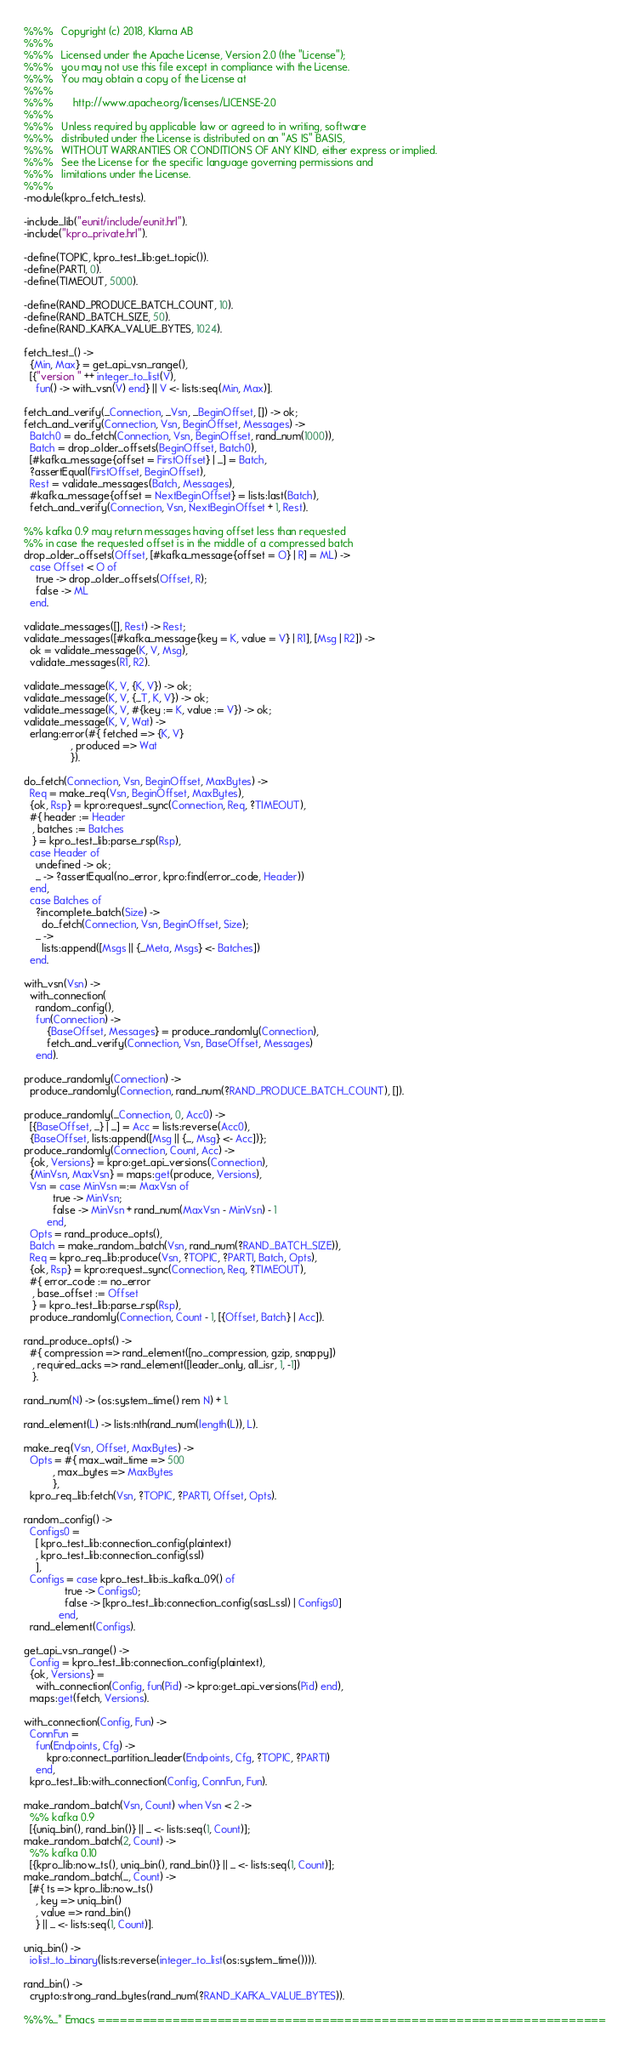<code> <loc_0><loc_0><loc_500><loc_500><_Erlang_>%%%   Copyright (c) 2018, Klarna AB
%%%
%%%   Licensed under the Apache License, Version 2.0 (the "License");
%%%   you may not use this file except in compliance with the License.
%%%   You may obtain a copy of the License at
%%%
%%%       http://www.apache.org/licenses/LICENSE-2.0
%%%
%%%   Unless required by applicable law or agreed to in writing, software
%%%   distributed under the License is distributed on an "AS IS" BASIS,
%%%   WITHOUT WARRANTIES OR CONDITIONS OF ANY KIND, either express or implied.
%%%   See the License for the specific language governing permissions and
%%%   limitations under the License.
%%%
-module(kpro_fetch_tests).

-include_lib("eunit/include/eunit.hrl").
-include("kpro_private.hrl").

-define(TOPIC, kpro_test_lib:get_topic()).
-define(PARTI, 0).
-define(TIMEOUT, 5000).

-define(RAND_PRODUCE_BATCH_COUNT, 10).
-define(RAND_BATCH_SIZE, 50).
-define(RAND_KAFKA_VALUE_BYTES, 1024).

fetch_test_() ->
  {Min, Max} = get_api_vsn_range(),
  [{"version " ++ integer_to_list(V),
    fun() -> with_vsn(V) end} || V <- lists:seq(Min, Max)].

fetch_and_verify(_Connection, _Vsn, _BeginOffset, []) -> ok;
fetch_and_verify(Connection, Vsn, BeginOffset, Messages) ->
  Batch0 = do_fetch(Connection, Vsn, BeginOffset, rand_num(1000)),
  Batch = drop_older_offsets(BeginOffset, Batch0),
  [#kafka_message{offset = FirstOffset} | _] = Batch,
  ?assertEqual(FirstOffset, BeginOffset),
  Rest = validate_messages(Batch, Messages),
  #kafka_message{offset = NextBeginOffset} = lists:last(Batch),
  fetch_and_verify(Connection, Vsn, NextBeginOffset + 1, Rest).

%% kafka 0.9 may return messages having offset less than requested
%% in case the requested offset is in the middle of a compressed batch
drop_older_offsets(Offset, [#kafka_message{offset = O} | R] = ML) ->
  case Offset < O of
    true -> drop_older_offsets(Offset, R);
    false -> ML
  end.

validate_messages([], Rest) -> Rest;
validate_messages([#kafka_message{key = K, value = V} | R1], [Msg | R2]) ->
  ok = validate_message(K, V, Msg),
  validate_messages(R1, R2).

validate_message(K, V, {K, V}) -> ok;
validate_message(K, V, {_T, K, V}) -> ok;
validate_message(K, V, #{key := K, value := V}) -> ok;
validate_message(K, V, Wat) ->
  erlang:error(#{ fetched => {K, V}
                , produced => Wat
                }).

do_fetch(Connection, Vsn, BeginOffset, MaxBytes) ->
  Req = make_req(Vsn, BeginOffset, MaxBytes),
  {ok, Rsp} = kpro:request_sync(Connection, Req, ?TIMEOUT),
  #{ header := Header
   , batches := Batches
   } = kpro_test_lib:parse_rsp(Rsp),
  case Header of
    undefined -> ok;
    _ -> ?assertEqual(no_error, kpro:find(error_code, Header))
  end,
  case Batches of
    ?incomplete_batch(Size) ->
      do_fetch(Connection, Vsn, BeginOffset, Size);
    _ ->
      lists:append([Msgs || {_Meta, Msgs} <- Batches])
  end.

with_vsn(Vsn) ->
  with_connection(
    random_config(),
    fun(Connection) ->
        {BaseOffset, Messages} = produce_randomly(Connection),
        fetch_and_verify(Connection, Vsn, BaseOffset, Messages)
    end).

produce_randomly(Connection) ->
  produce_randomly(Connection, rand_num(?RAND_PRODUCE_BATCH_COUNT), []).

produce_randomly(_Connection, 0, Acc0) ->
  [{BaseOffset, _} | _] = Acc = lists:reverse(Acc0),
  {BaseOffset, lists:append([Msg || {_, Msg} <- Acc])};
produce_randomly(Connection, Count, Acc) ->
  {ok, Versions} = kpro:get_api_versions(Connection),
  {MinVsn, MaxVsn} = maps:get(produce, Versions),
  Vsn = case MinVsn =:= MaxVsn of
          true -> MinVsn;
          false -> MinVsn + rand_num(MaxVsn - MinVsn) - 1
        end,
  Opts = rand_produce_opts(),
  Batch = make_random_batch(Vsn, rand_num(?RAND_BATCH_SIZE)),
  Req = kpro_req_lib:produce(Vsn, ?TOPIC, ?PARTI, Batch, Opts),
  {ok, Rsp} = kpro:request_sync(Connection, Req, ?TIMEOUT),
  #{ error_code := no_error
   , base_offset := Offset
   } = kpro_test_lib:parse_rsp(Rsp),
  produce_randomly(Connection, Count - 1, [{Offset, Batch} | Acc]).

rand_produce_opts() ->
  #{ compression => rand_element([no_compression, gzip, snappy])
   , required_acks => rand_element([leader_only, all_isr, 1, -1])
   }.

rand_num(N) -> (os:system_time() rem N) + 1.

rand_element(L) -> lists:nth(rand_num(length(L)), L).

make_req(Vsn, Offset, MaxBytes) ->
  Opts = #{ max_wait_time => 500
          , max_bytes => MaxBytes
          },
  kpro_req_lib:fetch(Vsn, ?TOPIC, ?PARTI, Offset, Opts).

random_config() ->
  Configs0 =
    [ kpro_test_lib:connection_config(plaintext)
    , kpro_test_lib:connection_config(ssl)
    ],
  Configs = case kpro_test_lib:is_kafka_09() of
              true -> Configs0;
              false -> [kpro_test_lib:connection_config(sasl_ssl) | Configs0]
            end,
  rand_element(Configs).

get_api_vsn_range() ->
  Config = kpro_test_lib:connection_config(plaintext),
  {ok, Versions} =
    with_connection(Config, fun(Pid) -> kpro:get_api_versions(Pid) end),
  maps:get(fetch, Versions).

with_connection(Config, Fun) ->
  ConnFun =
    fun(Endpoints, Cfg) ->
        kpro:connect_partition_leader(Endpoints, Cfg, ?TOPIC, ?PARTI)
    end,
  kpro_test_lib:with_connection(Config, ConnFun, Fun).

make_random_batch(Vsn, Count) when Vsn < 2 ->
  %% kafka 0.9
  [{uniq_bin(), rand_bin()} || _ <- lists:seq(1, Count)];
make_random_batch(2, Count) ->
  %% kafka 0.10
  [{kpro_lib:now_ts(), uniq_bin(), rand_bin()} || _ <- lists:seq(1, Count)];
make_random_batch(_, Count) ->
  [#{ ts => kpro_lib:now_ts()
    , key => uniq_bin()
    , value => rand_bin()
    } || _ <- lists:seq(1, Count)].

uniq_bin() ->
  iolist_to_binary(lists:reverse(integer_to_list(os:system_time()))).

rand_bin() ->
  crypto:strong_rand_bytes(rand_num(?RAND_KAFKA_VALUE_BYTES)).

%%%_* Emacs ====================================================================</code> 